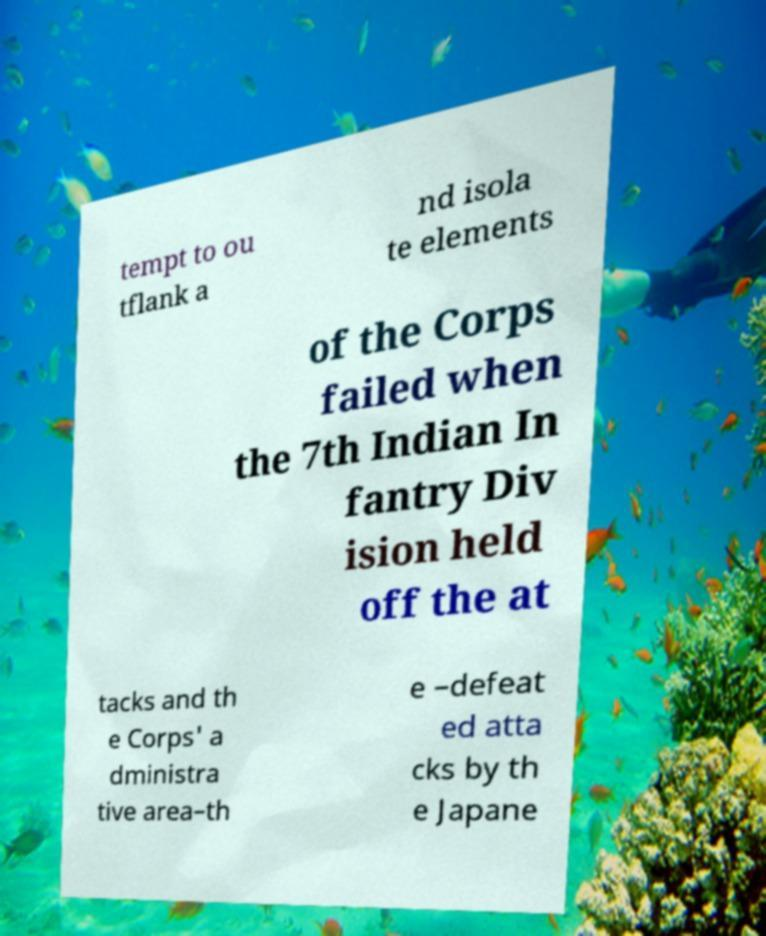Could you assist in decoding the text presented in this image and type it out clearly? tempt to ou tflank a nd isola te elements of the Corps failed when the 7th Indian In fantry Div ision held off the at tacks and th e Corps' a dministra tive area–th e –defeat ed atta cks by th e Japane 